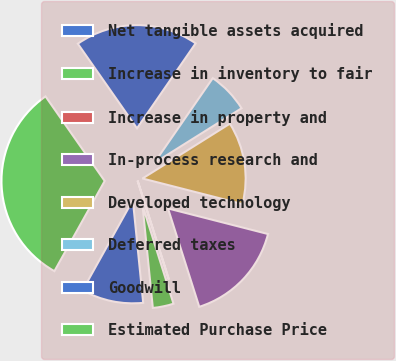Convert chart. <chart><loc_0><loc_0><loc_500><loc_500><pie_chart><fcel>Net tangible assets acquired<fcel>Increase in inventory to fair<fcel>Increase in property and<fcel>In-process research and<fcel>Developed technology<fcel>Deferred taxes<fcel>Goodwill<fcel>Estimated Purchase Price<nl><fcel>9.69%<fcel>3.26%<fcel>0.04%<fcel>16.12%<fcel>12.9%<fcel>6.47%<fcel>19.33%<fcel>32.19%<nl></chart> 